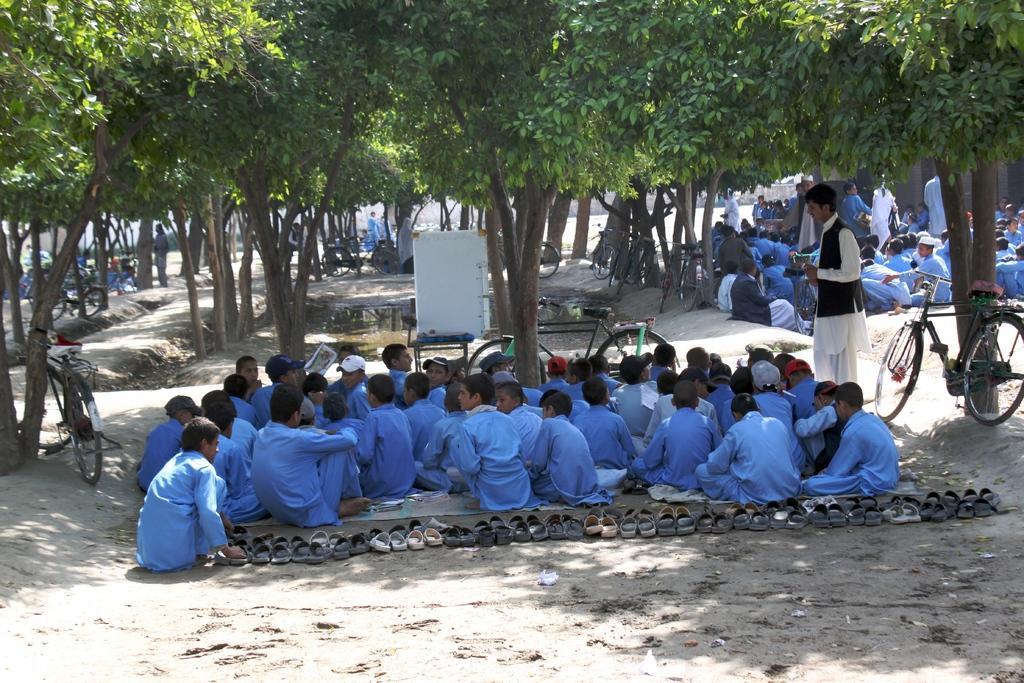Could you give a brief overview of what you see in this image? There are groups of people sitting on the ground and few people standing. These are the bicycles, which are parked. These are the trees with branches and leaves. I can see the pair of sandals arranged in an order. 